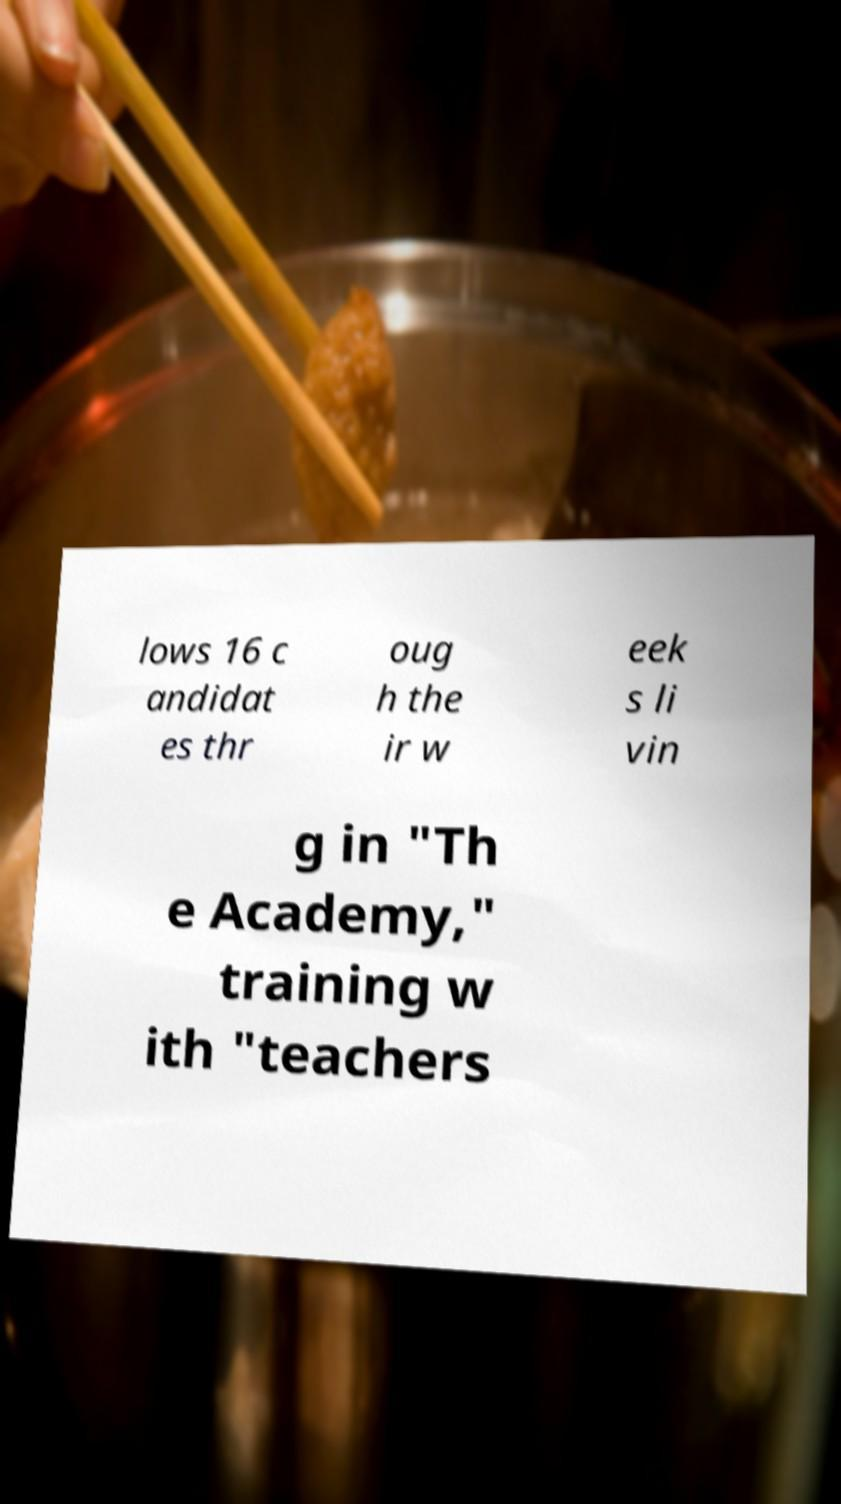Could you extract and type out the text from this image? lows 16 c andidat es thr oug h the ir w eek s li vin g in "Th e Academy," training w ith "teachers 